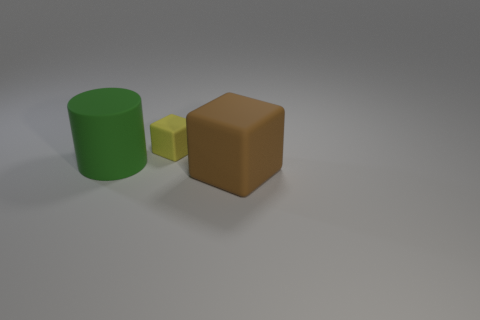What number of things are cubes behind the brown cube or big brown rubber things?
Your response must be concise. 2. Are there an equal number of brown objects that are on the right side of the brown matte thing and big cubes?
Make the answer very short. No. Do the brown matte block and the cylinder have the same size?
Your answer should be compact. Yes. The other rubber thing that is the same size as the green object is what color?
Offer a very short reply. Brown. There is a brown matte block; is it the same size as the cylinder on the left side of the small object?
Your answer should be compact. Yes. What number of cubes have the same color as the matte cylinder?
Your answer should be compact. 0. What number of things are either cyan metallic spheres or rubber objects to the left of the large brown rubber cube?
Offer a very short reply. 2. There is a matte cylinder in front of the small cube; is its size the same as the object in front of the green thing?
Give a very brief answer. Yes. Are there any large cylinders made of the same material as the yellow thing?
Keep it short and to the point. Yes. What is the shape of the large green rubber object?
Offer a terse response. Cylinder. 